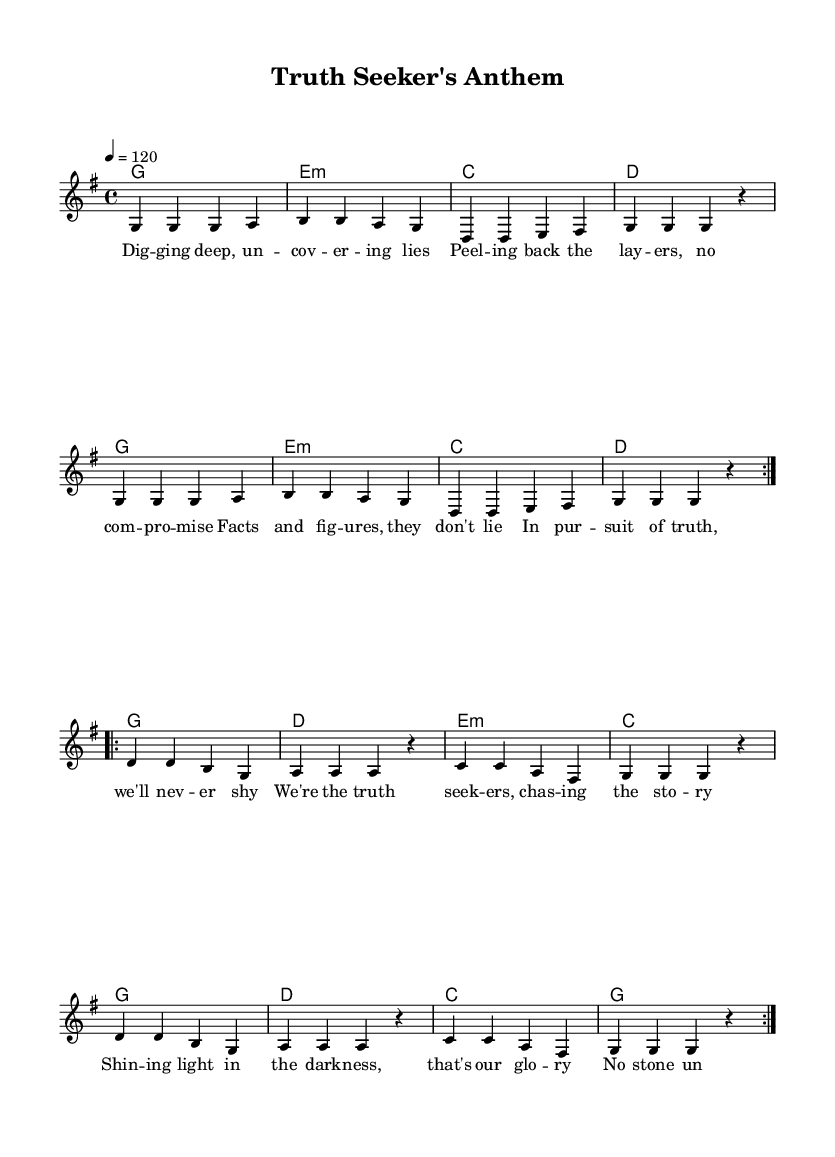What is the key signature of this music? The key signature is G major, which has one sharp (F#). This can be determined by looking at the key signature indication at the beginning of the score.
Answer: G major What is the time signature of this music? The time signature is 4/4, which can be identified by the notation at the beginning of the score that indicates four beats per measure.
Answer: 4/4 What is the tempo marking of this piece? The tempo marking is 120, indicated by the tempo written in quarter note beats per minute at the beginning of the score.
Answer: 120 How many times is the melody repeated in the score? The melody is repeated two times as indicated by the repeat volta markings in the melody section. Each repeat consists of the same series of notes.
Answer: 2 times What is the theme of the lyrics in the chorus? The theme of the lyrics in the chorus focuses on truth-seeking and uncovering stories, as it describes the pursuit of truth and doing so with determination. This is evident from the lines of the chorus that emphasize “light in the darkness” and “no secret untold.”
Answer: Truth-seeking How does the harmony change in the second part of the melody? The harmony in the second part moves from the chords of G, E minor, C, and D to a different progression of G, D, E minor, and C, signaling a shift in the emotional or dynamic quality of the music as it progresses. This is shown in the harmonic notation corresponding to the melody.
Answer: Changes from G, E minor, C, D to G, D, E minor, C What kind of song structure is used in this piece? The song structure follows a verse-chorus format, where the verse introduces the theme and the chorus emphasizes the main message. This is typical in pop music and can be recognized by the labeling of the verse and chorus within the score.
Answer: Verse-chorus structure 